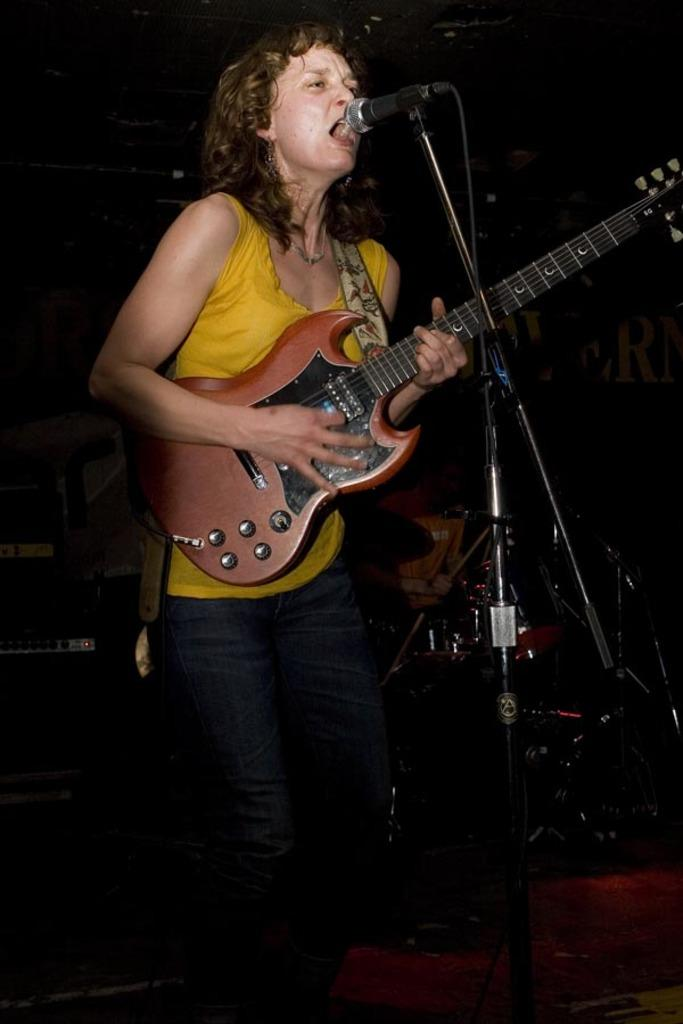Who is the main subject in the image? There is a woman in the image. What is the woman doing in the image? The woman is standing, singing a song, and playing a guitar. What is the woman holding in the image? The woman is holding a microphone, which is attached to a microphone stand. Can you describe the person in the background of the image? The person in the background is sitting and playing drums. What type of chin can be seen on the robin in the image? There is no robin present in the image; it features a woman singing and playing a guitar, along with a person playing drums in the background. What branch is the woman sitting on in the image? The woman is standing, not sitting, and there is no branch in the image. 